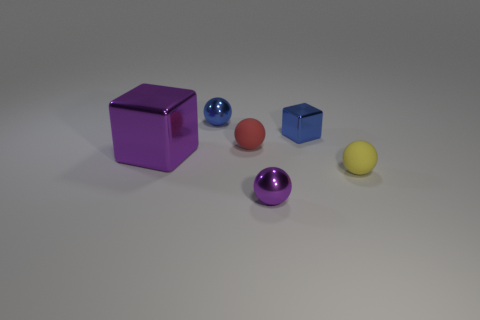What material is the yellow thing in front of the small rubber thing that is on the left side of the rubber thing to the right of the tiny blue cube?
Keep it short and to the point. Rubber. There is a blue object that is left of the small blue cube; is its shape the same as the small metallic object in front of the small shiny block?
Your response must be concise. Yes. What number of other objects are the same material as the red sphere?
Your answer should be very brief. 1. Is the material of the tiny yellow ball in front of the big purple block the same as the red ball that is behind the tiny yellow object?
Ensure brevity in your answer.  Yes. The tiny purple thing that is the same material as the tiny blue ball is what shape?
Provide a short and direct response. Sphere. Is there anything else that has the same color as the large shiny cube?
Provide a succinct answer. Yes. How many tiny matte things are there?
Ensure brevity in your answer.  2. There is a thing that is both in front of the big shiny object and right of the purple sphere; what shape is it?
Provide a short and direct response. Sphere. What is the shape of the small shiny thing to the left of the metal sphere that is right of the blue metal object behind the small blue cube?
Offer a terse response. Sphere. What is the ball that is in front of the tiny metal block and behind the tiny yellow rubber sphere made of?
Give a very brief answer. Rubber. 